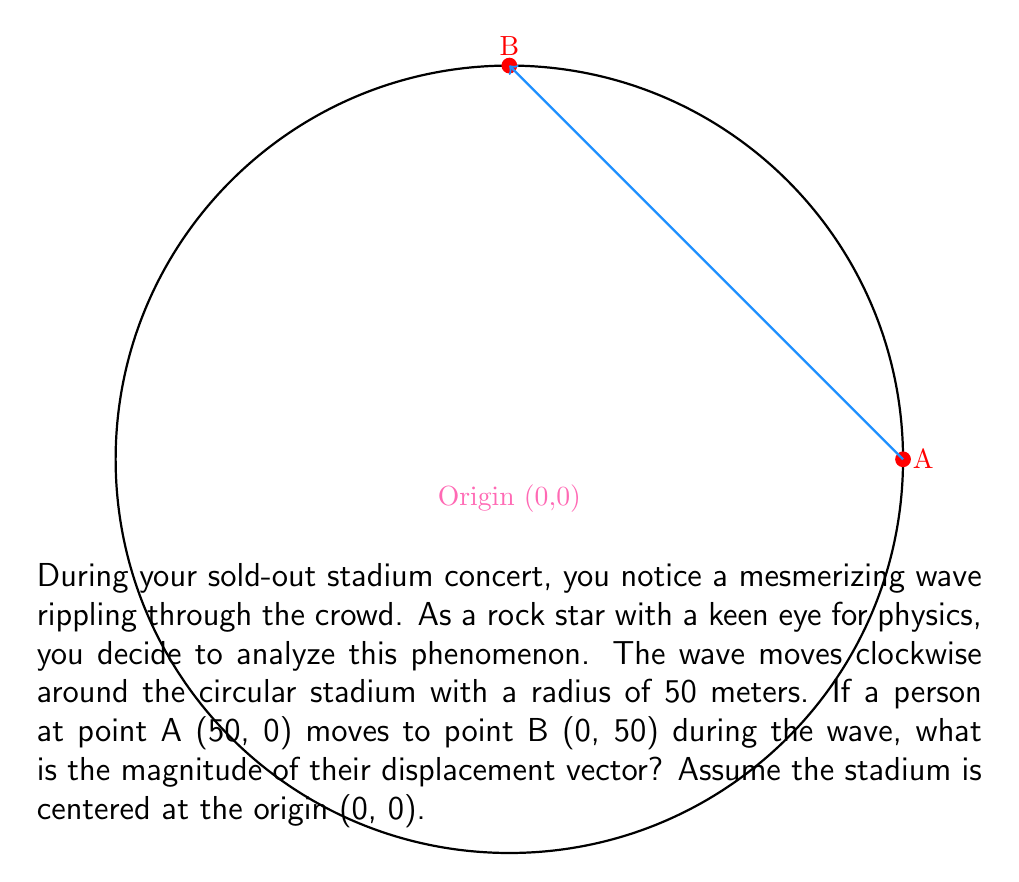Show me your answer to this math problem. Let's approach this step-by-step:

1) The displacement vector is the vector from point A to point B. We can calculate this using the coordinates of these points.

2) Point A coordinates: (50, 0)
   Point B coordinates: (0, 50)

3) The displacement vector $\vec{d}$ is given by:
   $$\vec{d} = (x_B - x_A, y_B - y_A)$$

4) Substituting the values:
   $$\vec{d} = (0 - 50, 50 - 0) = (-50, 50)$$

5) To find the magnitude of this vector, we use the Pythagorean theorem:
   $$|\vec{d}| = \sqrt{(-50)^2 + (50)^2}$$

6) Simplifying:
   $$|\vec{d}| = \sqrt{2500 + 2500} = \sqrt{5000}$$

7) Simplifying further:
   $$|\vec{d}| = 10\sqrt{50} \approx 70.71 \text{ meters}$$

Therefore, the magnitude of the displacement vector is $10\sqrt{50}$ meters.
Answer: $10\sqrt{50}$ meters 